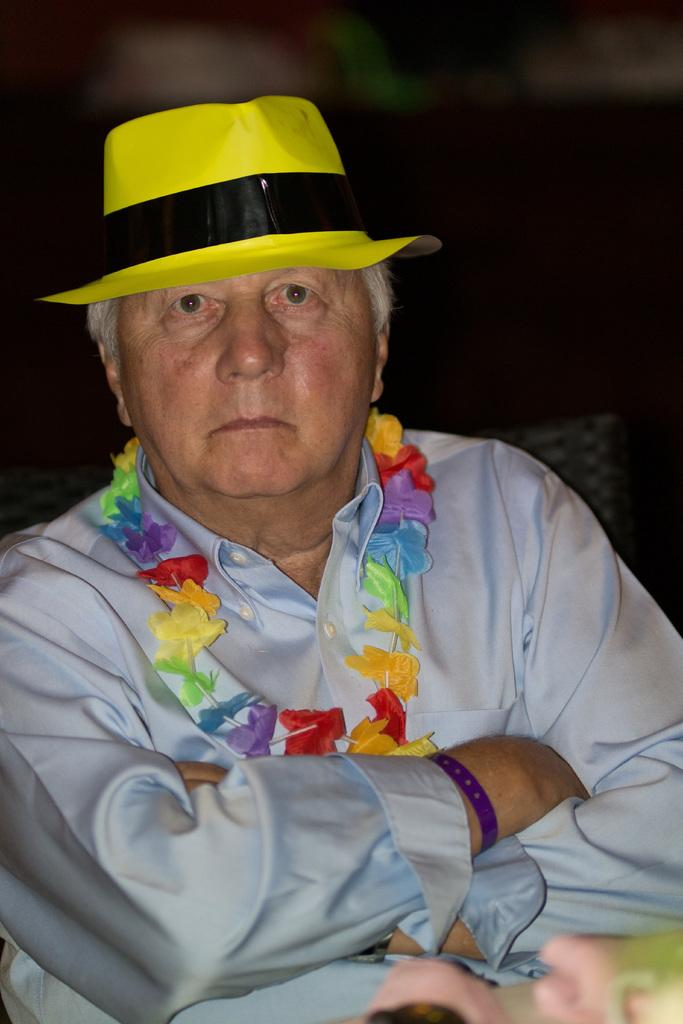What is the main subject in the foreground of the image? There is a person in the foreground of the image. What is the person wearing around their neck? The person is wearing a garland. What type of headwear is the person wearing? The person is wearing a hat. How would you describe the background of the image? The background of the image is blurred. How many beds are visible in the image? There are no beds visible in the image. What type of beast can be seen interacting with the person in the image? There is no beast present in the image; only the person wearing a garland and hat is visible. 